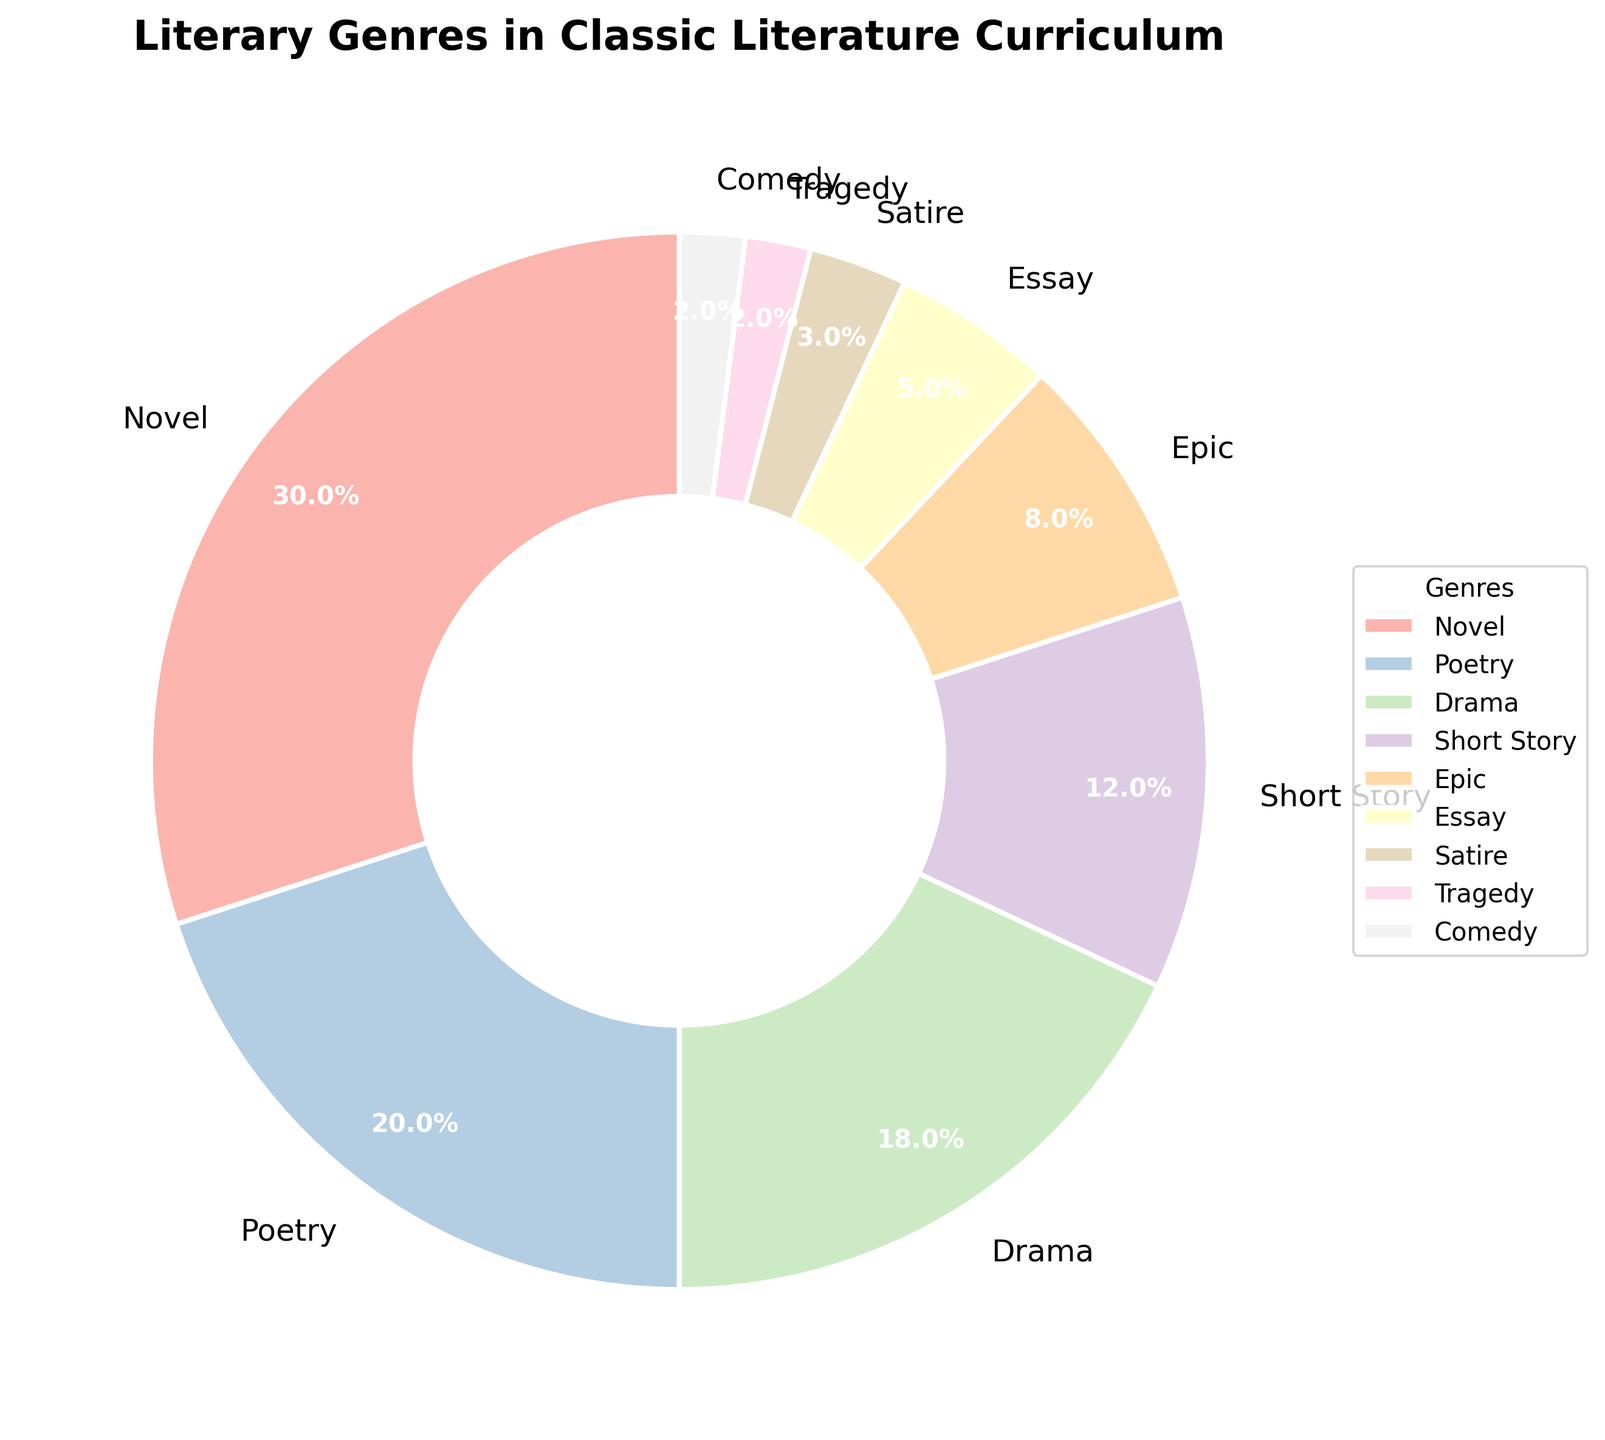What is the most represented genre in the classic literature curriculum? The most represented genre can be identified by looking for the segment with the largest percentage. The "Novel" segment occupies 30%, which is the largest value among all genres.
Answer: Novel Which genre has a smaller representation: Essay or Satire? By comparing the percentages of Essay and Satire, Essay has 5% while Satire has 3%. Since 3% is less than 5%, Satire has a smaller representation.
Answer: Satire What is the combined percentage of Drama, Short Story, and Epic genres? To find the combined percentage, add the individual percentages of Drama (18%), Short Story (12%), and Epic (8%). Thus, 18 + 12 + 8 = 38%.
Answer: 38% How much larger is the representation of Poetry compared to Comedy? To determine how much larger Poetry's percentage is compared to Comedy's, subtract Comedy's percentage (2%) from Poetry's percentage (20%). Thus, 20 - 2 = 18%.
Answer: 18% What is the average representation percentage of the genres Poetry, Tragedy, and Comedy? To find the average percentage, sum the percentages of Poetry (20%), Tragedy (2%), and Comedy (2%) and divide by the number of genres. Thus, (20 + 2 + 2) / 3 = 24 / 3 = 8%.
Answer: 8% Among the following genres: Short Story, Epic, Essay, and Satire, which one is the second most represented? First, list the percentages: Short Story (12%), Epic (8%), Essay (5%), and Satire (3%). The second most represented genre among them is Epic with 8%, as it follows Short Story with 12%.
Answer: Epic Which genre has the least representation and what is its percentage? The genre with the least representation has the smallest percentage. Both Tragedy and Comedy have the smallest values, each with 2%.
Answer: Tragedy, Comedy (2%) What is the difference in representation percentage between the most and least represented genres? The most represented genre is Novel at 30%, and the least represented are Tragedy and Comedy at 2%. The difference is calculated as 30 - 2 = 28%.
Answer: 28% Which genres have a representation percentage greater than 10%? To determine this, identify genres with percentages above 10%. Novel (30%), Poetry (20%), Drama (18%), and Short Story (12%) all have percentages greater than 10%.
Answer: Novel, Poetry, Drama, Short Story How many genres have a representation percentage of 5% or less? To find the number of genres with percentages of 5% or less, count the segments involved: Essay (5%), Satire (3%), Tragedy (2%), and Comedy (2%). There are 4 genres fitting this criterion.
Answer: 4 